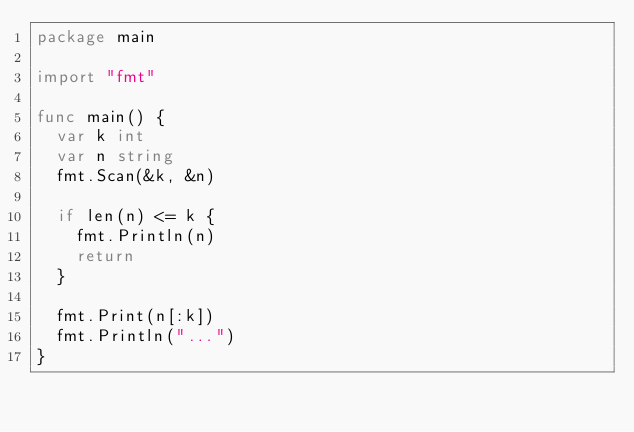Convert code to text. <code><loc_0><loc_0><loc_500><loc_500><_Go_>package main

import "fmt"

func main() {
	var k int
	var n string
	fmt.Scan(&k, &n)

	if len(n) <= k {
		fmt.Println(n)
		return
	}

	fmt.Print(n[:k])
	fmt.Println("...")
}
</code> 